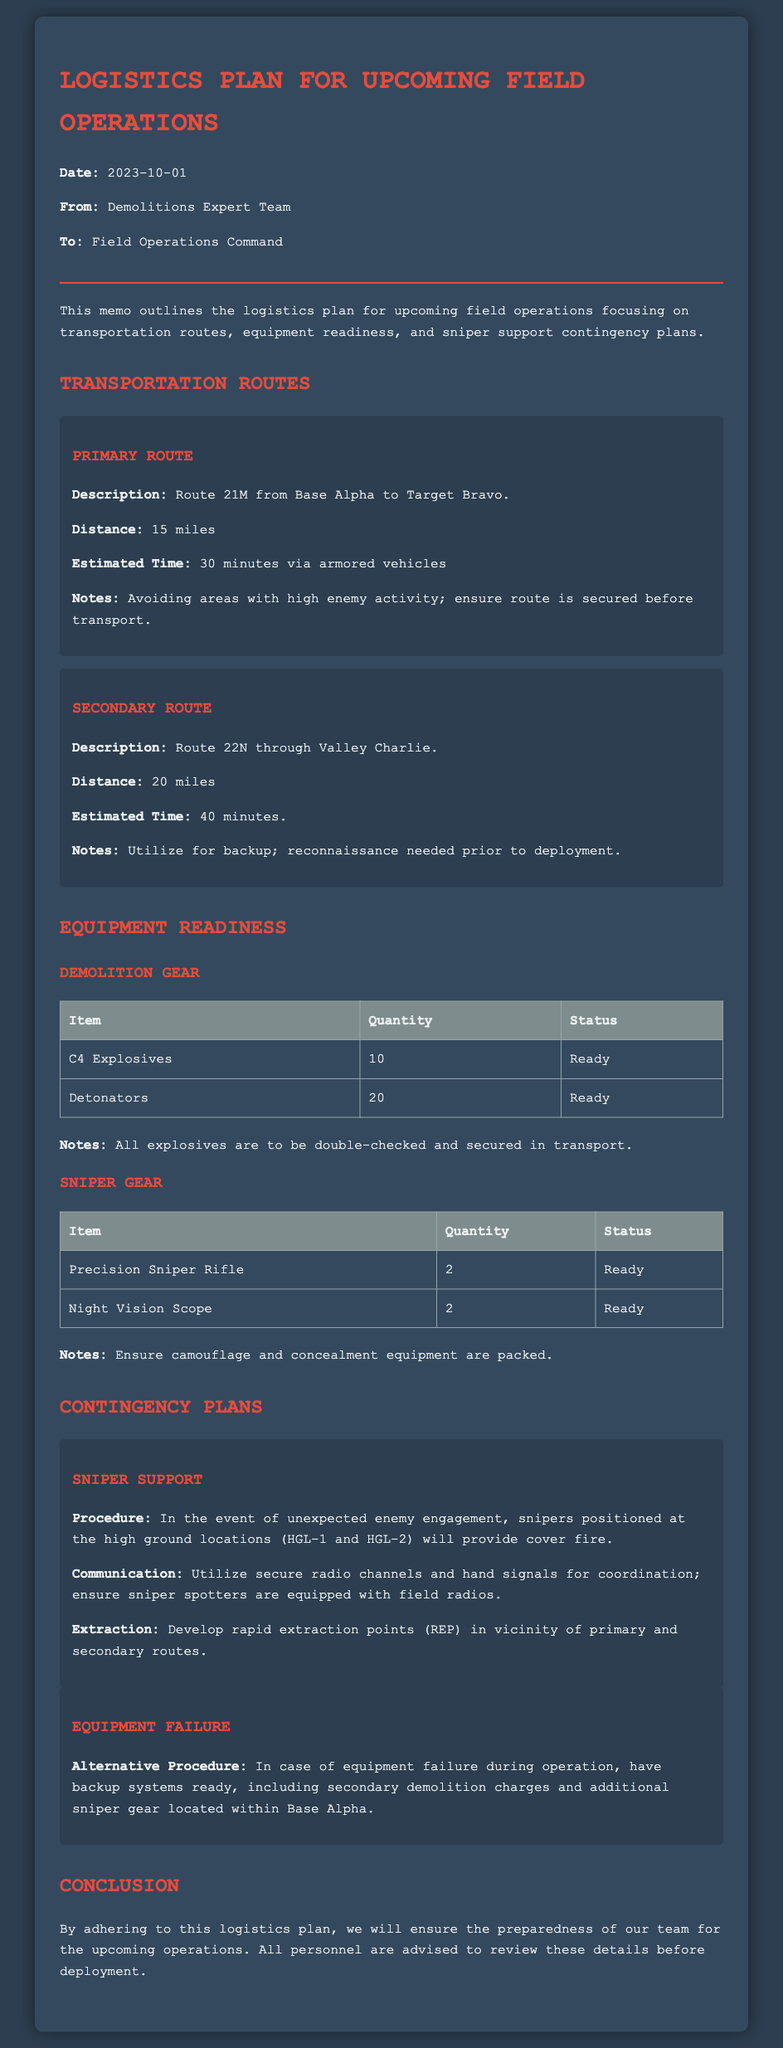What is the primary route for transportation? The primary route is described in the document as Route 21M from Base Alpha to Target Bravo.
Answer: Route 21M What is the distance of the secondary route? The secondary route's distance is explicitly stated as 20 miles in the document.
Answer: 20 miles How many C4 explosives are ready for the operation? The document lists that there are 10 C4 explosives ready.
Answer: 10 What are the two high ground locations for sniper support? The memo mentions HGL-1 and HGL-2 as the designated high ground locations for snipers.
Answer: HGL-1 and HGL-2 What is the communication method for sniper support coordination? The memo specifies that secure radio channels and hand signals are the methods for communication with sniper support.
Answer: Secure radio channels and hand signals What is the estimated time for the primary route? According to the memo, the estimated time to travel the primary route is 30 minutes.
Answer: 30 minutes How many precision sniper rifles are designated for the field operation? The equipment section of the memo indicates that 2 precision sniper rifles are ready for use.
Answer: 2 What alternative procedure is mentioned for equipment failure? The document states that backup systems, including secondary demolition charges, are the alternative procedure in case of equipment failure.
Answer: Backup systems including secondary demolition charges What type of document is this? The structured format and content define this document as a logistics plan memo.
Answer: Memo 